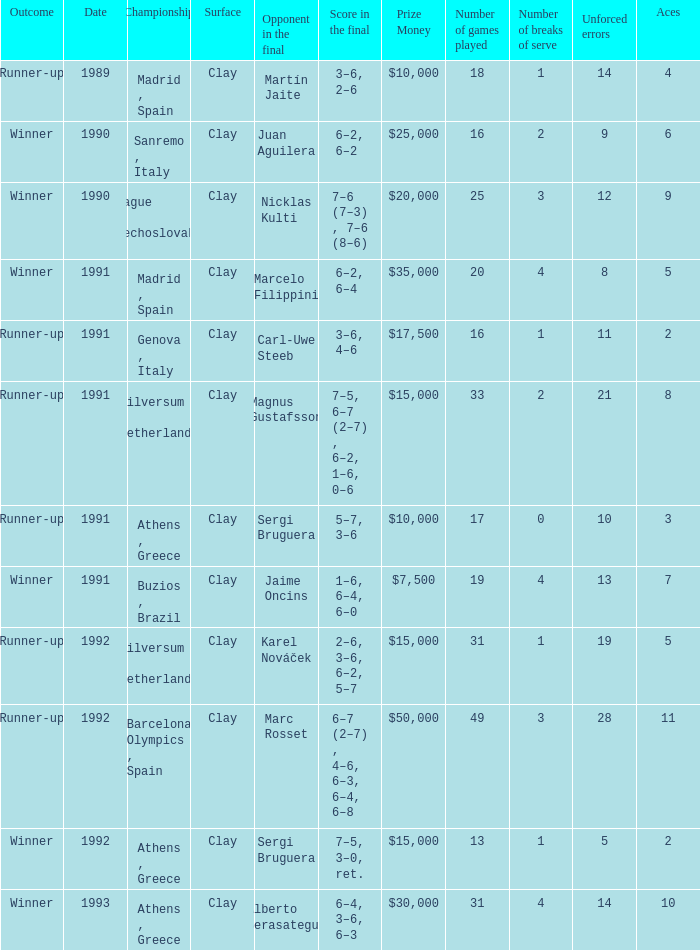What is Opponent In The Final, when Date is before 1991, and when Outcome is "Runner-Up"? Martín Jaite. 